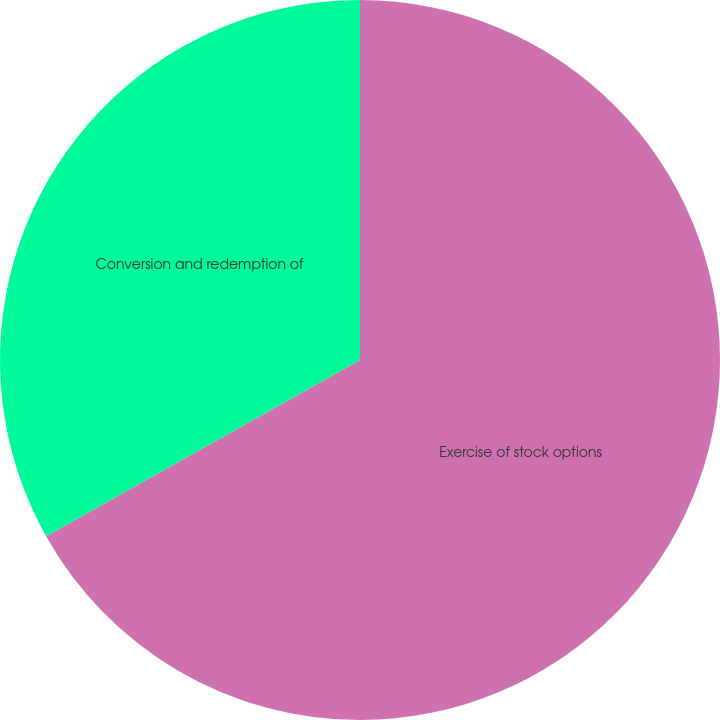Convert chart. <chart><loc_0><loc_0><loc_500><loc_500><pie_chart><fcel>Exercise of stock options<fcel>Conversion and redemption of<nl><fcel>66.86%<fcel>33.14%<nl></chart> 